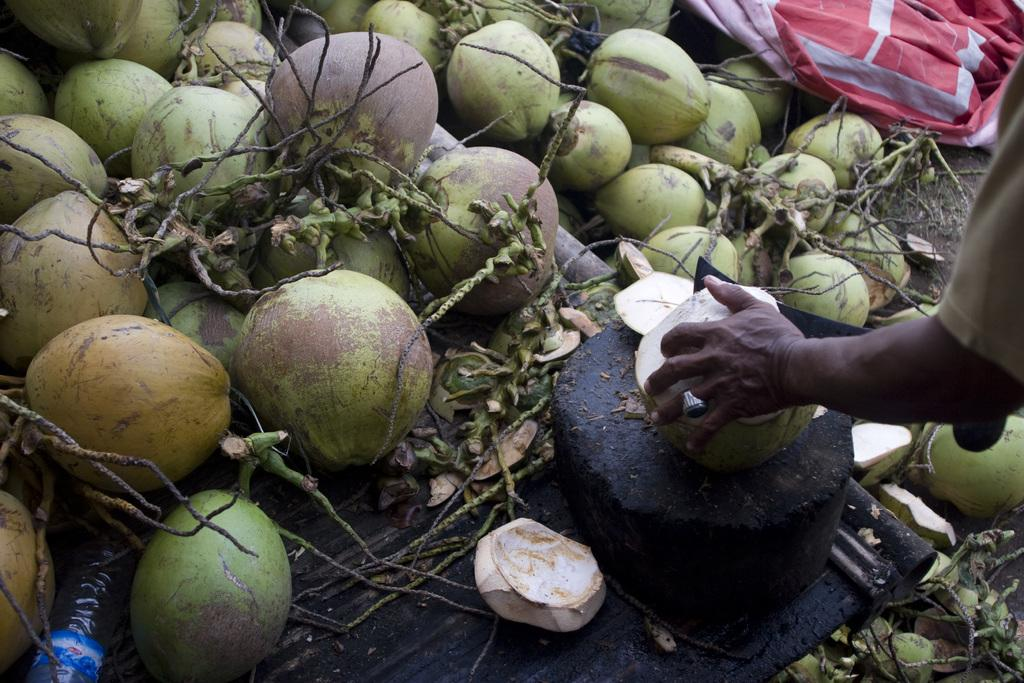What is the main subject of the image? The main subject of the image is coconuts. Can you describe the position of the coconuts in the image? The coconuts are in the center of the image. What is the person's hand doing in the image? The person's hand is cutting a coconut. What hobbies does the person's brother have, as seen in the image? There is no information about the person's brother or their hobbies in the image. 